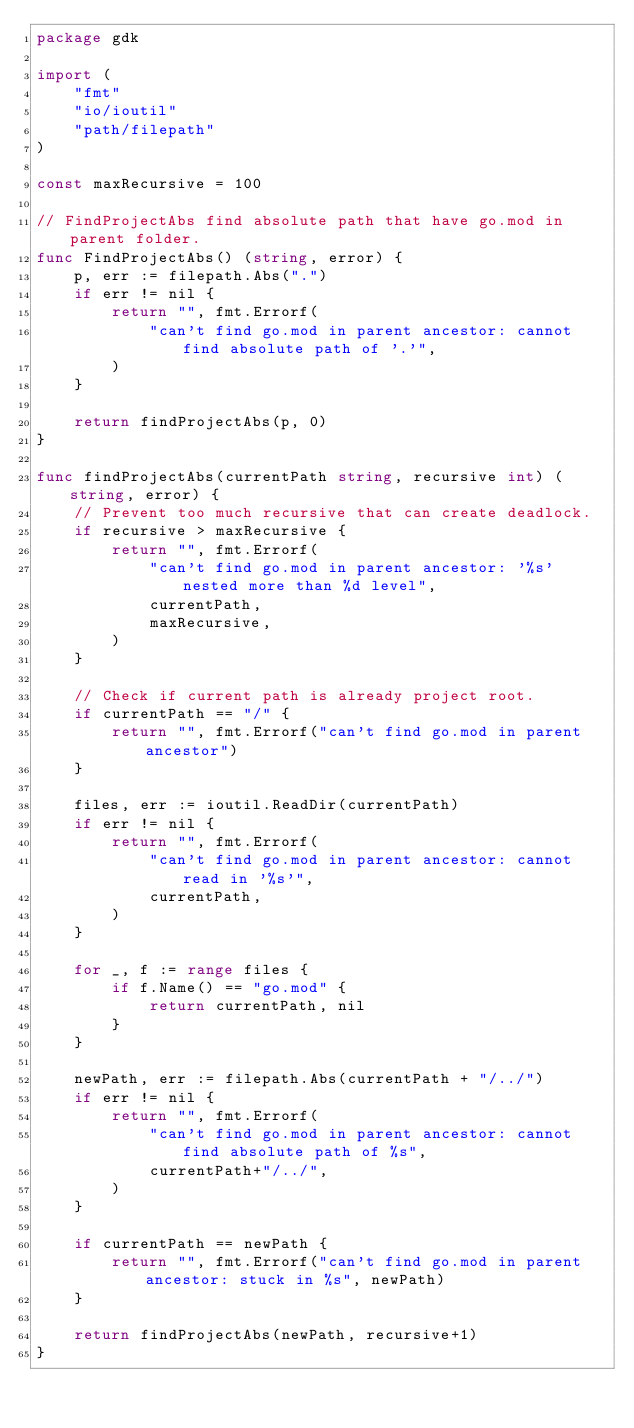Convert code to text. <code><loc_0><loc_0><loc_500><loc_500><_Go_>package gdk

import (
	"fmt"
	"io/ioutil"
	"path/filepath"
)

const maxRecursive = 100

// FindProjectAbs find absolute path that have go.mod in parent folder.
func FindProjectAbs() (string, error) {
	p, err := filepath.Abs(".")
	if err != nil {
		return "", fmt.Errorf(
			"can't find go.mod in parent ancestor: cannot find absolute path of '.'",
		)
	}

	return findProjectAbs(p, 0)
}

func findProjectAbs(currentPath string, recursive int) (string, error) {
	// Prevent too much recursive that can create deadlock.
	if recursive > maxRecursive {
		return "", fmt.Errorf(
			"can't find go.mod in parent ancestor: '%s' nested more than %d level",
			currentPath,
			maxRecursive,
		)
	}

	// Check if current path is already project root.
	if currentPath == "/" {
		return "", fmt.Errorf("can't find go.mod in parent ancestor")
	}

	files, err := ioutil.ReadDir(currentPath)
	if err != nil {
		return "", fmt.Errorf(
			"can't find go.mod in parent ancestor: cannot read in '%s'",
			currentPath,
		)
	}

	for _, f := range files {
		if f.Name() == "go.mod" {
			return currentPath, nil
		}
	}

	newPath, err := filepath.Abs(currentPath + "/../")
	if err != nil {
		return "", fmt.Errorf(
			"can't find go.mod in parent ancestor: cannot find absolute path of %s",
			currentPath+"/../",
		)
	}

	if currentPath == newPath {
		return "", fmt.Errorf("can't find go.mod in parent ancestor: stuck in %s", newPath)
	}

	return findProjectAbs(newPath, recursive+1)
}
</code> 